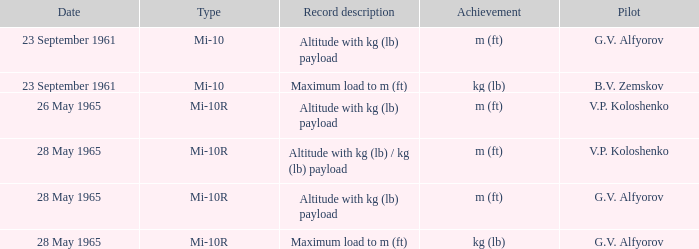When did the g.v. alfyorov's pilot, a record portrayal of altitude with kg (lb) payload, and a model of mi-10 occur? 23 September 1961. 